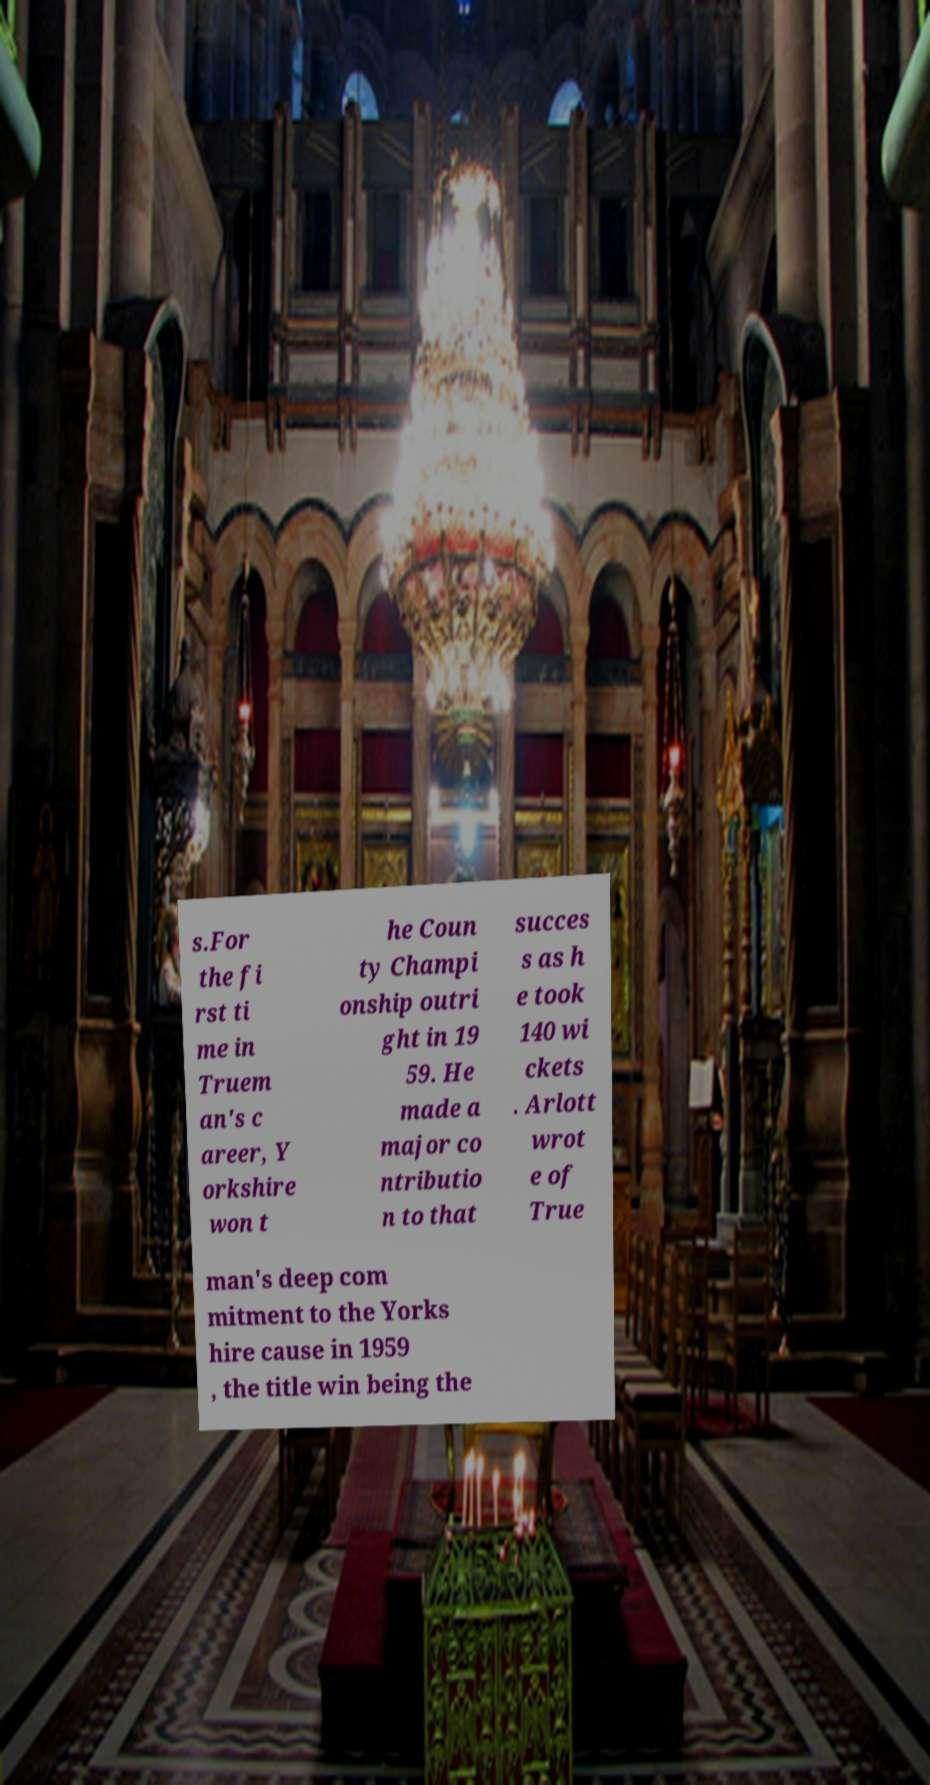There's text embedded in this image that I need extracted. Can you transcribe it verbatim? s.For the fi rst ti me in Truem an's c areer, Y orkshire won t he Coun ty Champi onship outri ght in 19 59. He made a major co ntributio n to that succes s as h e took 140 wi ckets . Arlott wrot e of True man's deep com mitment to the Yorks hire cause in 1959 , the title win being the 